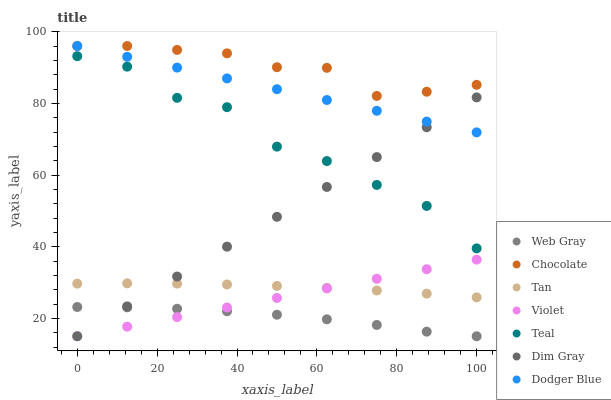Does Web Gray have the minimum area under the curve?
Answer yes or no. Yes. Does Chocolate have the maximum area under the curve?
Answer yes or no. Yes. Does Chocolate have the minimum area under the curve?
Answer yes or no. No. Does Web Gray have the maximum area under the curve?
Answer yes or no. No. Is Violet the smoothest?
Answer yes or no. Yes. Is Teal the roughest?
Answer yes or no. Yes. Is Chocolate the smoothest?
Answer yes or no. No. Is Chocolate the roughest?
Answer yes or no. No. Does Dim Gray have the lowest value?
Answer yes or no. Yes. Does Chocolate have the lowest value?
Answer yes or no. No. Does Dodger Blue have the highest value?
Answer yes or no. Yes. Does Web Gray have the highest value?
Answer yes or no. No. Is Violet less than Dodger Blue?
Answer yes or no. Yes. Is Chocolate greater than Web Gray?
Answer yes or no. Yes. Does Web Gray intersect Violet?
Answer yes or no. Yes. Is Web Gray less than Violet?
Answer yes or no. No. Is Web Gray greater than Violet?
Answer yes or no. No. Does Violet intersect Dodger Blue?
Answer yes or no. No. 